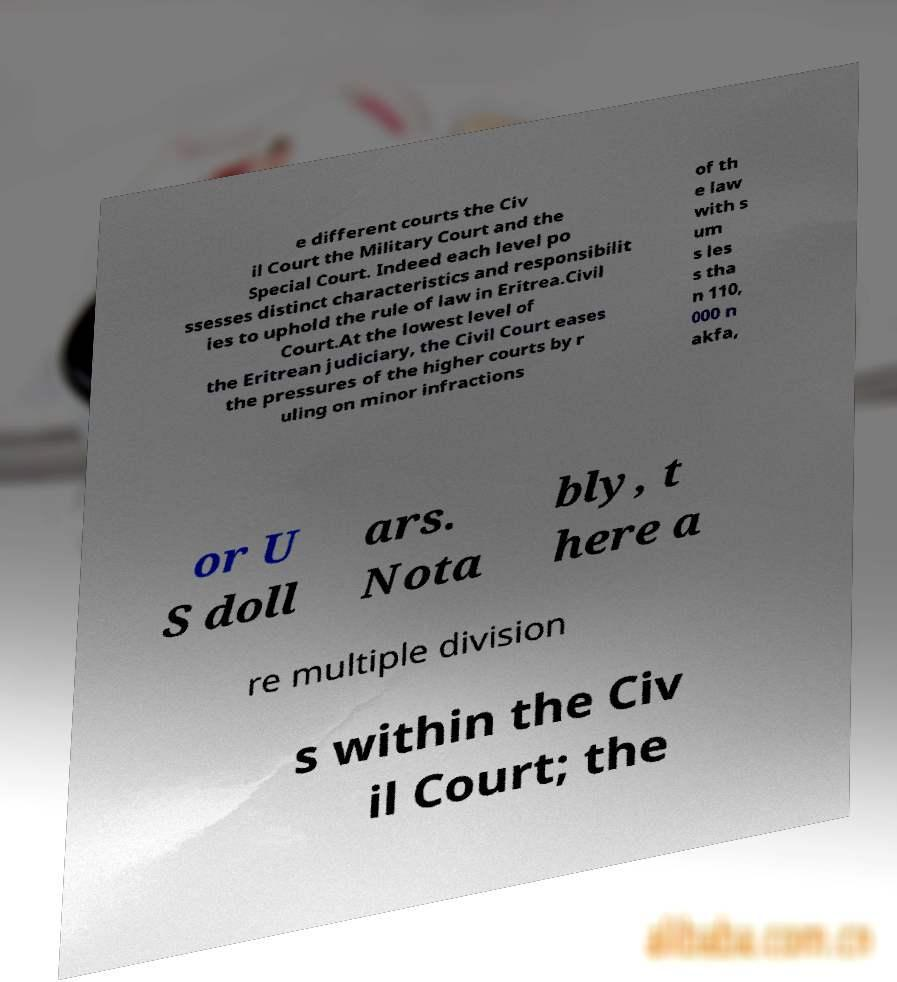What messages or text are displayed in this image? I need them in a readable, typed format. e different courts the Civ il Court the Military Court and the Special Court. Indeed each level po ssesses distinct characteristics and responsibilit ies to uphold the rule of law in Eritrea.Civil Court.At the lowest level of the Eritrean judiciary, the Civil Court eases the pressures of the higher courts by r uling on minor infractions of th e law with s um s les s tha n 110, 000 n akfa, or U S doll ars. Nota bly, t here a re multiple division s within the Civ il Court; the 